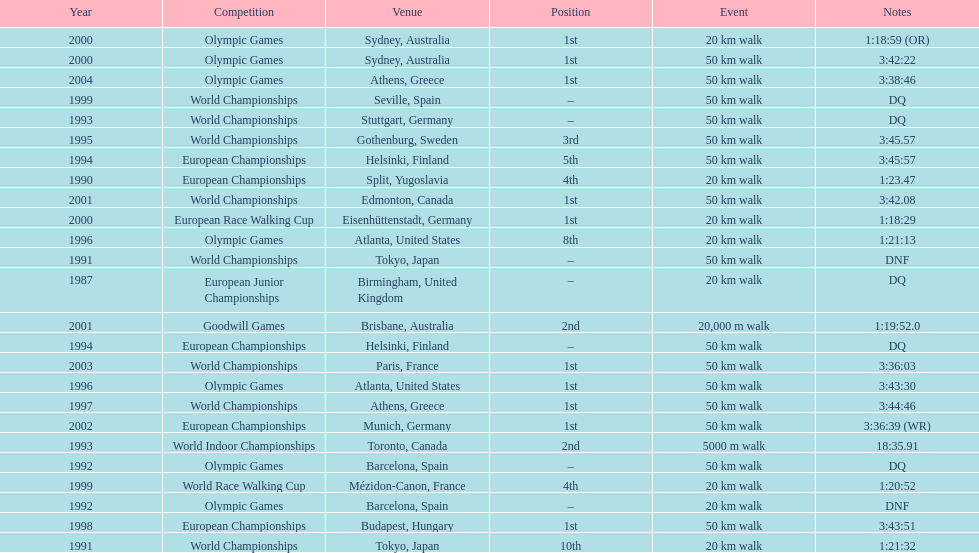What was the name of the competition that took place before the olympic games in 1996? World Championships. 